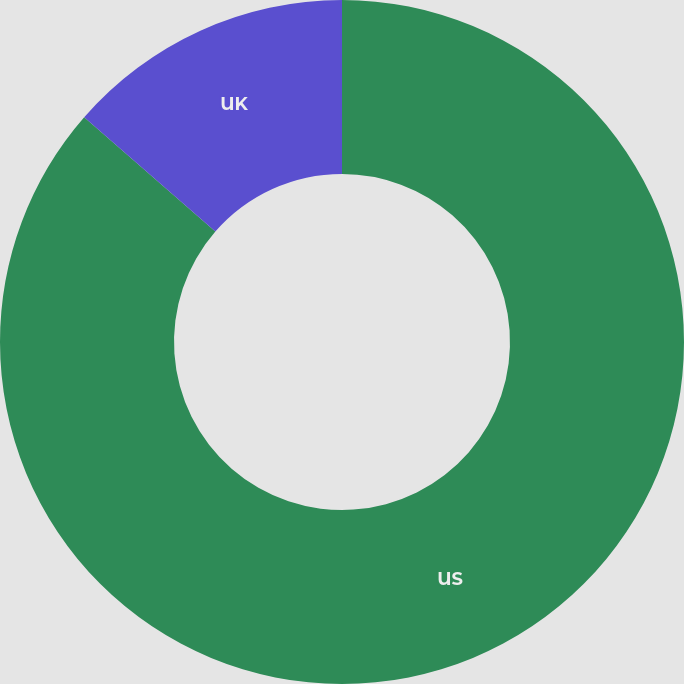Convert chart. <chart><loc_0><loc_0><loc_500><loc_500><pie_chart><fcel>US<fcel>UK<nl><fcel>86.41%<fcel>13.59%<nl></chart> 